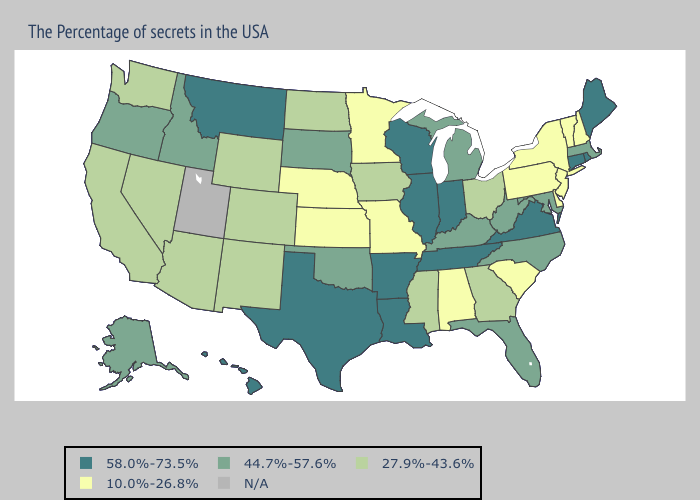What is the value of New York?
Keep it brief. 10.0%-26.8%. Does Tennessee have the lowest value in the USA?
Short answer required. No. What is the highest value in states that border Oregon?
Answer briefly. 44.7%-57.6%. Name the states that have a value in the range 58.0%-73.5%?
Answer briefly. Maine, Rhode Island, Connecticut, Virginia, Indiana, Tennessee, Wisconsin, Illinois, Louisiana, Arkansas, Texas, Montana, Hawaii. Does the first symbol in the legend represent the smallest category?
Give a very brief answer. No. What is the value of Kansas?
Quick response, please. 10.0%-26.8%. What is the highest value in states that border Illinois?
Quick response, please. 58.0%-73.5%. Does Illinois have the lowest value in the MidWest?
Keep it brief. No. Does Minnesota have the lowest value in the USA?
Keep it brief. Yes. Does New Jersey have the lowest value in the USA?
Answer briefly. Yes. What is the value of New Jersey?
Concise answer only. 10.0%-26.8%. What is the highest value in states that border Kansas?
Keep it brief. 44.7%-57.6%. What is the value of Utah?
Write a very short answer. N/A. What is the lowest value in the MidWest?
Answer briefly. 10.0%-26.8%. What is the highest value in states that border Maine?
Answer briefly. 10.0%-26.8%. 